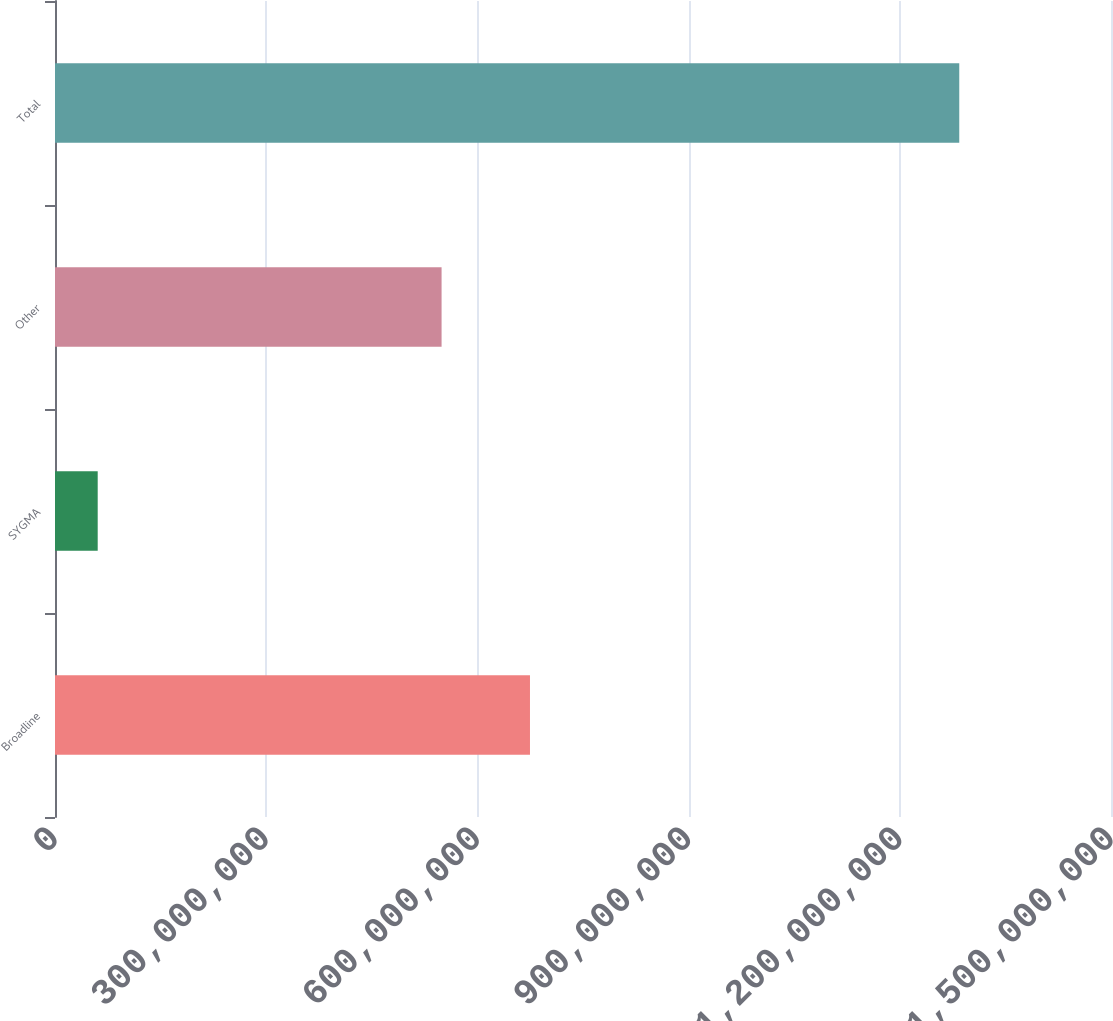<chart> <loc_0><loc_0><loc_500><loc_500><bar_chart><fcel>Broadline<fcel>SYGMA<fcel>Other<fcel>Total<nl><fcel>6.74682e+08<fcel>6.066e+07<fcel>5.49117e+08<fcel>1.28446e+09<nl></chart> 